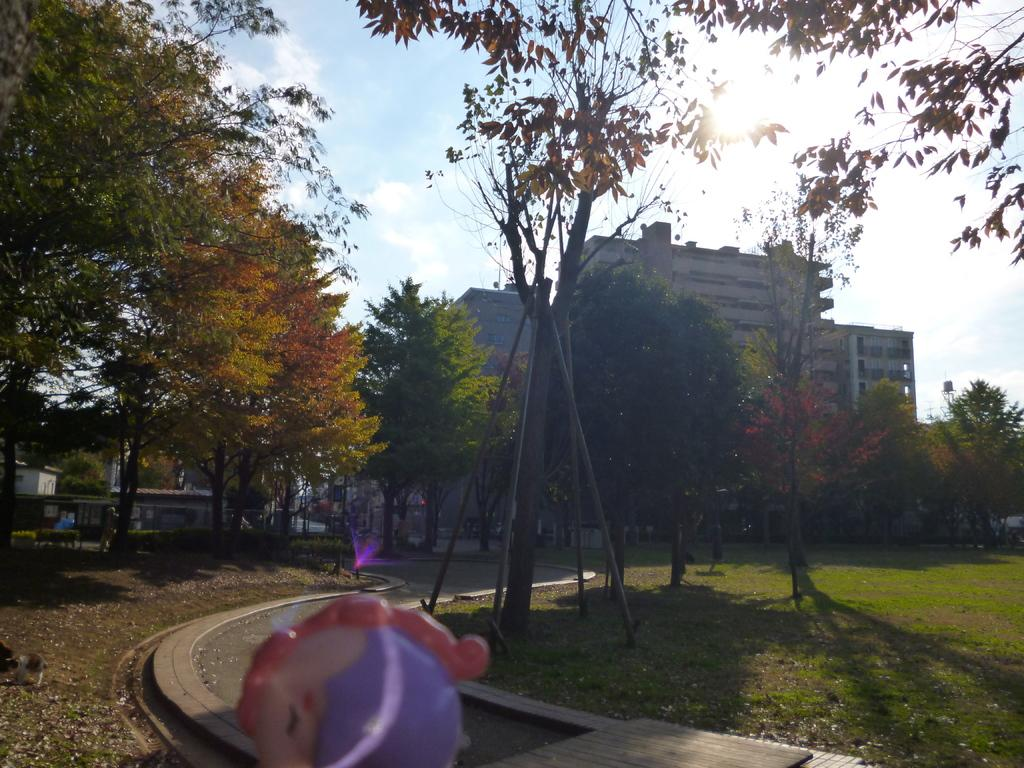What type of surface is visible in the image? The image contains ground. What can be found on the ground in the image? There are lights and trees on the ground in the image. What type of structure is present in the image? There is a building in the image. What is visible at the top of the image? The sky is visible at the top of the image. What is the source of light in the image? Sunlight is present in the image. What type of object is visible in the image that is typically associated with play? There is a toy visible in the image. What scent can be detected in the image? There is no information about a scent in the image, so it cannot be determined. --- Facts: 1. There is a person in the image. 2. The person is wearing a hat. 3. The person is holding a book. 4. There is a table in the image. 5. The table has a lamp on it. Absurd Topics: parrot, ocean, bicycle Conversation: What is the main subject of the image? There is a person in the image. What is the person wearing? The person is wearing a hat. What object is the person holding? The person is holding a book. What type of furniture is present in the image? There is a table in the image. What is on the table in the image? The table has a lamp on it. Reasoning: Let's think step by step in order to produce the conversation. We start by identifying the main subject of the image, which is the person. Then, we describe the person's attire and the object they are holding. Next, we mention the presence of a table and describe what is on it. Each question is designed to elicit a specific detail about the image that is known from the provided facts. Absurd Question/Answer: Can you see a parrot sitting on the person's shoulder in the image? There is no parrot present in the image. What type of ocean can be seen in the background of the image? There is no ocean visible in the image. 